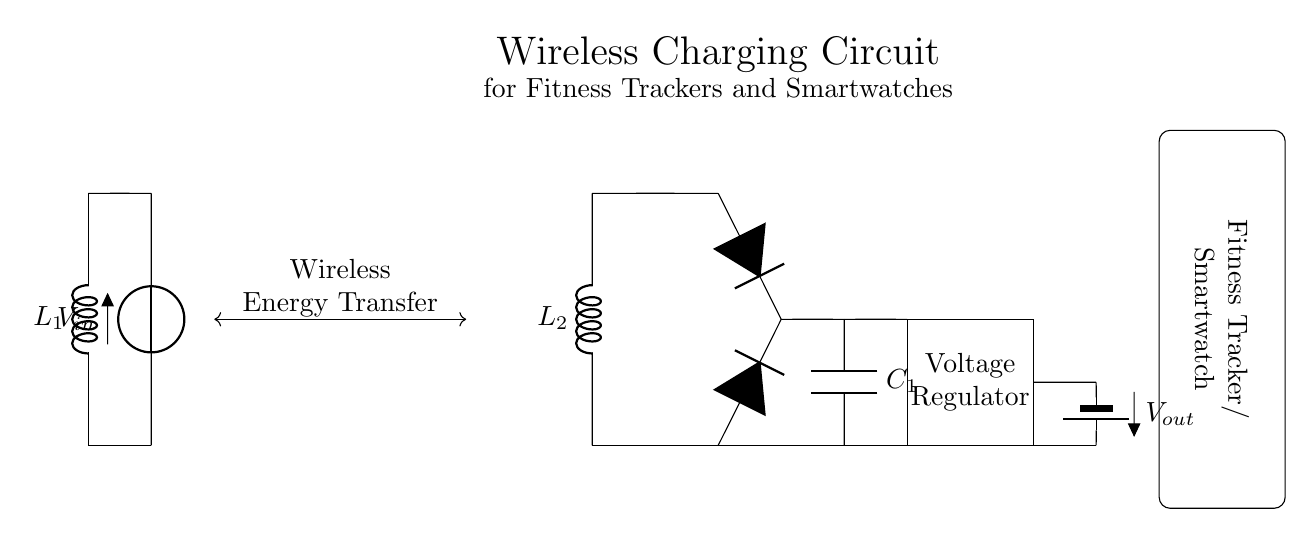What is the purpose of the coils in this circuit? The coils, L1 and L2, are used for wireless energy transfer between the transmitter and receiver. They create an electromagnetic field that allows power to be transferred without direct contact.
Answer: Wireless energy transfer What type of component is used for rectification? The circuit uses diodes (D) for rectification, which convert the alternating current generated in the receiver coil into direct current suitable for charging.
Answer: Diodes How many capacitors are in the circuit? There is one capacitor (C1) included in the circuit that smooths the rectified output voltage.
Answer: One What does the voltage regulator do in the circuit? The voltage regulator stabilizes the output voltage to ensure the connected devices receive a consistent and safe voltage level during charging.
Answer: Stabilizes output voltage What is the input voltage noted in the circuit? The input voltage (Vin) is not specified in numerical values on the diagram, but it is indicated as a general symbol.
Answer: Vin Which component is responsible for energy transfer in this circuit? The two inductors, L1 and L2, are primarily responsible for the energy transfer through magnetic coupling.
Answer: Inductors 